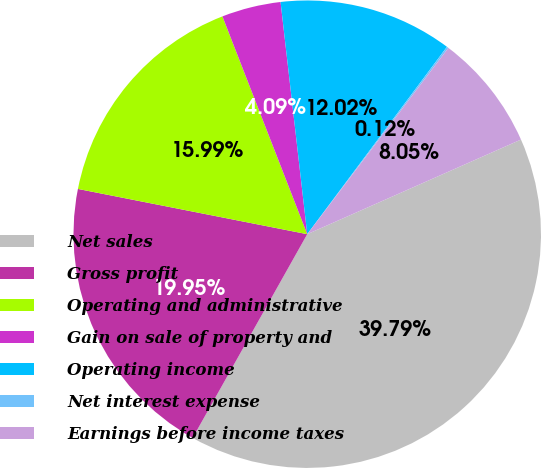<chart> <loc_0><loc_0><loc_500><loc_500><pie_chart><fcel>Net sales<fcel>Gross profit<fcel>Operating and administrative<fcel>Gain on sale of property and<fcel>Operating income<fcel>Net interest expense<fcel>Earnings before income taxes<nl><fcel>39.79%<fcel>19.95%<fcel>15.99%<fcel>4.09%<fcel>12.02%<fcel>0.12%<fcel>8.05%<nl></chart> 